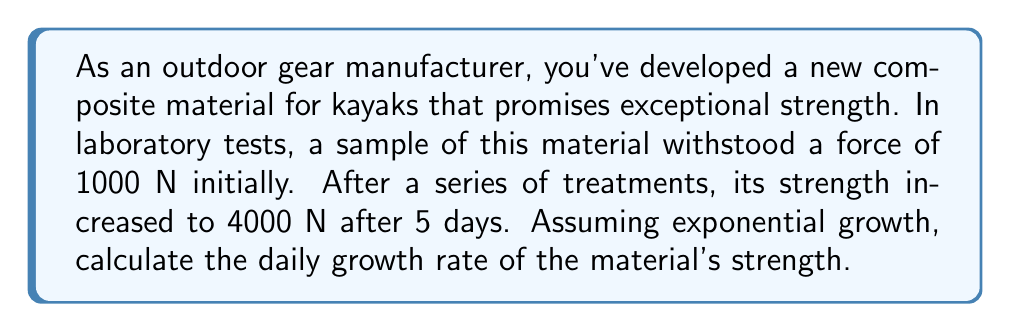What is the answer to this math problem? To solve this problem, we'll use the exponential growth formula:

$$A = P(1 + r)^t$$

Where:
$A$ = Final amount (4000 N)
$P$ = Initial amount (1000 N)
$r$ = Daily growth rate (what we're solving for)
$t$ = Time period (5 days)

Let's solve for $r$:

1) Substitute the known values into the formula:
   $$4000 = 1000(1 + r)^5$$

2) Divide both sides by 1000:
   $$4 = (1 + r)^5$$

3) Take the 5th root of both sides:
   $$\sqrt[5]{4} = 1 + r$$

4) Subtract 1 from both sides:
   $$\sqrt[5]{4} - 1 = r$$

5) Calculate the value:
   $$r = \sqrt[5]{4} - 1 \approx 1.3195 - 1 = 0.3195$$

6) Convert to a percentage:
   $$r \approx 0.3195 \times 100\% = 31.95\%$$

Therefore, the daily growth rate of the material's strength is approximately 31.95%.
Answer: The daily growth rate of the new kayak material's strength is approximately 31.95%. 